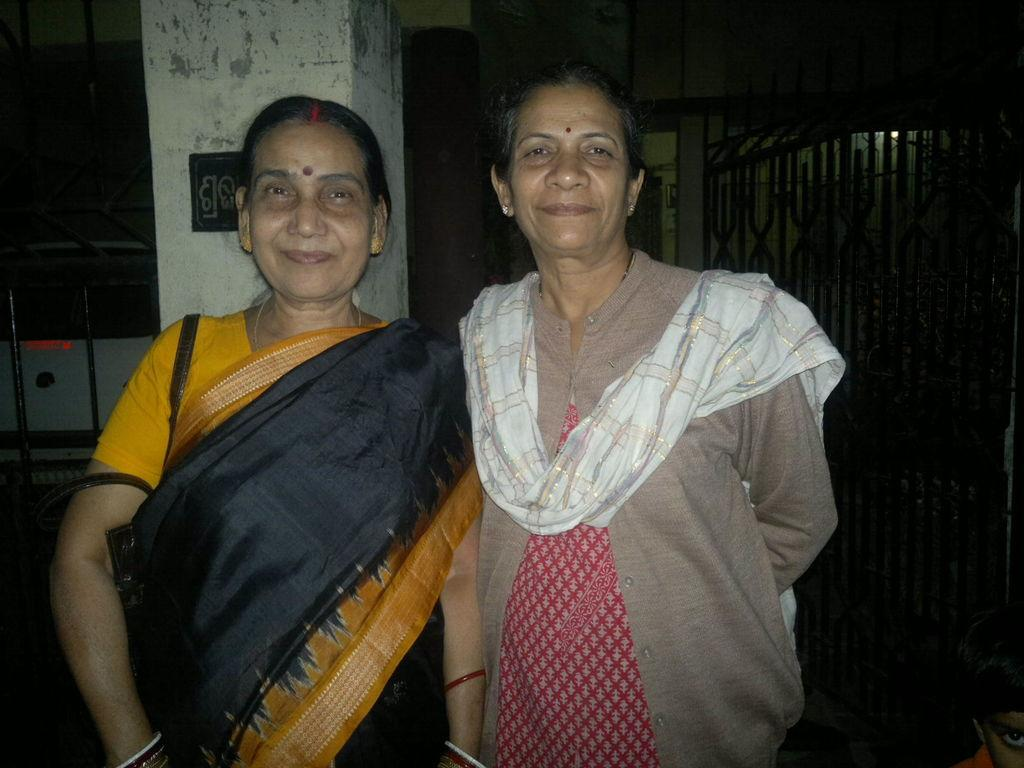How many people are in the image? There are two women in the image. What is the facial expression of the women? The women are smiling. What can be seen in the background of the image? There is a pillar, a board, and a grill in the background of the image. What type of sweater is the woman on the left wearing in the image? There is no sweater visible in the image; both women are wearing dresses. 